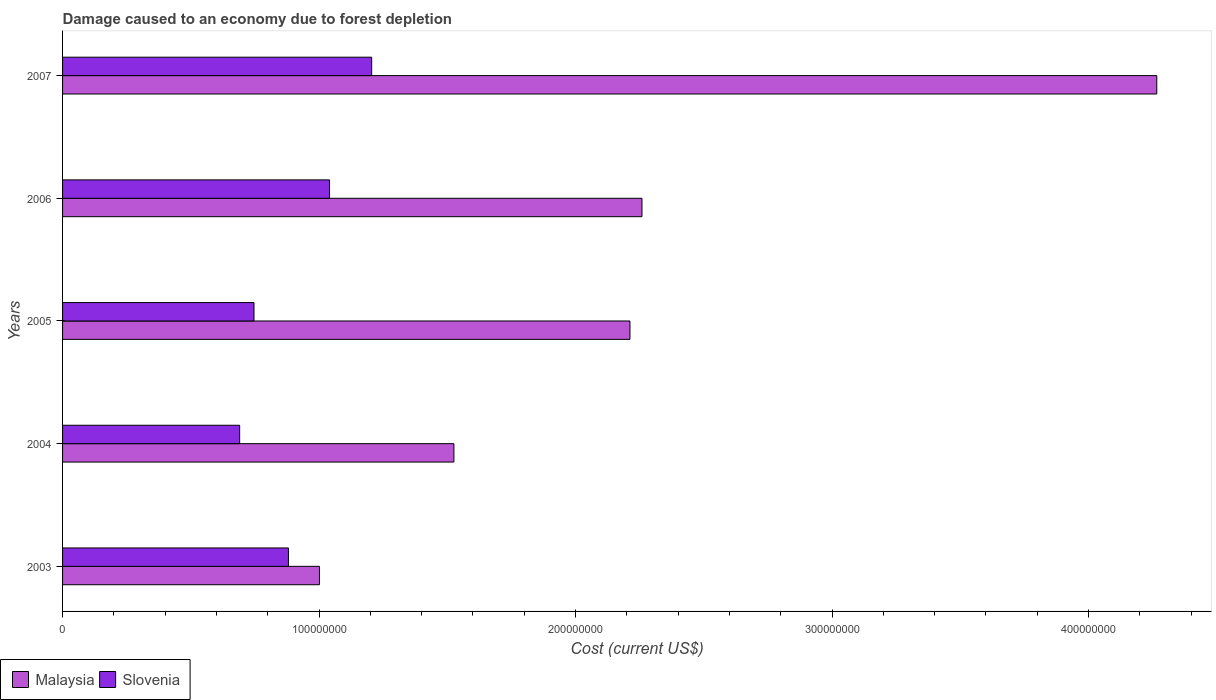How many different coloured bars are there?
Offer a very short reply. 2. How many bars are there on the 5th tick from the top?
Keep it short and to the point. 2. How many bars are there on the 5th tick from the bottom?
Offer a terse response. 2. What is the label of the 3rd group of bars from the top?
Give a very brief answer. 2005. What is the cost of damage caused due to forest depletion in Malaysia in 2004?
Your answer should be compact. 1.53e+08. Across all years, what is the maximum cost of damage caused due to forest depletion in Malaysia?
Give a very brief answer. 4.27e+08. Across all years, what is the minimum cost of damage caused due to forest depletion in Slovenia?
Make the answer very short. 6.90e+07. What is the total cost of damage caused due to forest depletion in Malaysia in the graph?
Keep it short and to the point. 1.13e+09. What is the difference between the cost of damage caused due to forest depletion in Malaysia in 2003 and that in 2004?
Provide a short and direct response. -5.24e+07. What is the difference between the cost of damage caused due to forest depletion in Slovenia in 2007 and the cost of damage caused due to forest depletion in Malaysia in 2003?
Provide a succinct answer. 2.04e+07. What is the average cost of damage caused due to forest depletion in Malaysia per year?
Offer a terse response. 2.25e+08. In the year 2007, what is the difference between the cost of damage caused due to forest depletion in Malaysia and cost of damage caused due to forest depletion in Slovenia?
Make the answer very short. 3.06e+08. What is the ratio of the cost of damage caused due to forest depletion in Slovenia in 2004 to that in 2006?
Your answer should be compact. 0.66. What is the difference between the highest and the second highest cost of damage caused due to forest depletion in Slovenia?
Your answer should be compact. 1.64e+07. What is the difference between the highest and the lowest cost of damage caused due to forest depletion in Malaysia?
Keep it short and to the point. 3.26e+08. In how many years, is the cost of damage caused due to forest depletion in Malaysia greater than the average cost of damage caused due to forest depletion in Malaysia taken over all years?
Offer a very short reply. 2. What does the 1st bar from the top in 2003 represents?
Keep it short and to the point. Slovenia. What does the 1st bar from the bottom in 2006 represents?
Your answer should be very brief. Malaysia. How many bars are there?
Ensure brevity in your answer.  10. Are all the bars in the graph horizontal?
Keep it short and to the point. Yes. How many years are there in the graph?
Offer a terse response. 5. Are the values on the major ticks of X-axis written in scientific E-notation?
Provide a succinct answer. No. Does the graph contain grids?
Ensure brevity in your answer.  No. How many legend labels are there?
Offer a terse response. 2. What is the title of the graph?
Your response must be concise. Damage caused to an economy due to forest depletion. Does "Ecuador" appear as one of the legend labels in the graph?
Your response must be concise. No. What is the label or title of the X-axis?
Make the answer very short. Cost (current US$). What is the label or title of the Y-axis?
Provide a succinct answer. Years. What is the Cost (current US$) of Malaysia in 2003?
Offer a terse response. 1.00e+08. What is the Cost (current US$) in Slovenia in 2003?
Your answer should be compact. 8.81e+07. What is the Cost (current US$) of Malaysia in 2004?
Your answer should be very brief. 1.53e+08. What is the Cost (current US$) in Slovenia in 2004?
Provide a short and direct response. 6.90e+07. What is the Cost (current US$) of Malaysia in 2005?
Ensure brevity in your answer.  2.21e+08. What is the Cost (current US$) in Slovenia in 2005?
Provide a short and direct response. 7.46e+07. What is the Cost (current US$) in Malaysia in 2006?
Your response must be concise. 2.26e+08. What is the Cost (current US$) in Slovenia in 2006?
Offer a very short reply. 1.04e+08. What is the Cost (current US$) in Malaysia in 2007?
Provide a short and direct response. 4.27e+08. What is the Cost (current US$) in Slovenia in 2007?
Provide a succinct answer. 1.21e+08. Across all years, what is the maximum Cost (current US$) of Malaysia?
Ensure brevity in your answer.  4.27e+08. Across all years, what is the maximum Cost (current US$) in Slovenia?
Make the answer very short. 1.21e+08. Across all years, what is the minimum Cost (current US$) of Malaysia?
Offer a terse response. 1.00e+08. Across all years, what is the minimum Cost (current US$) of Slovenia?
Ensure brevity in your answer.  6.90e+07. What is the total Cost (current US$) of Malaysia in the graph?
Offer a terse response. 1.13e+09. What is the total Cost (current US$) of Slovenia in the graph?
Your response must be concise. 4.56e+08. What is the difference between the Cost (current US$) in Malaysia in 2003 and that in 2004?
Provide a short and direct response. -5.24e+07. What is the difference between the Cost (current US$) of Slovenia in 2003 and that in 2004?
Offer a very short reply. 1.90e+07. What is the difference between the Cost (current US$) of Malaysia in 2003 and that in 2005?
Provide a short and direct response. -1.21e+08. What is the difference between the Cost (current US$) of Slovenia in 2003 and that in 2005?
Give a very brief answer. 1.34e+07. What is the difference between the Cost (current US$) in Malaysia in 2003 and that in 2006?
Provide a succinct answer. -1.26e+08. What is the difference between the Cost (current US$) in Slovenia in 2003 and that in 2006?
Provide a succinct answer. -1.60e+07. What is the difference between the Cost (current US$) in Malaysia in 2003 and that in 2007?
Your answer should be very brief. -3.26e+08. What is the difference between the Cost (current US$) in Slovenia in 2003 and that in 2007?
Give a very brief answer. -3.25e+07. What is the difference between the Cost (current US$) of Malaysia in 2004 and that in 2005?
Your answer should be very brief. -6.86e+07. What is the difference between the Cost (current US$) of Slovenia in 2004 and that in 2005?
Offer a terse response. -5.59e+06. What is the difference between the Cost (current US$) of Malaysia in 2004 and that in 2006?
Provide a succinct answer. -7.33e+07. What is the difference between the Cost (current US$) in Slovenia in 2004 and that in 2006?
Provide a succinct answer. -3.50e+07. What is the difference between the Cost (current US$) in Malaysia in 2004 and that in 2007?
Offer a terse response. -2.74e+08. What is the difference between the Cost (current US$) of Slovenia in 2004 and that in 2007?
Give a very brief answer. -5.15e+07. What is the difference between the Cost (current US$) in Malaysia in 2005 and that in 2006?
Give a very brief answer. -4.68e+06. What is the difference between the Cost (current US$) in Slovenia in 2005 and that in 2006?
Make the answer very short. -2.94e+07. What is the difference between the Cost (current US$) in Malaysia in 2005 and that in 2007?
Provide a short and direct response. -2.05e+08. What is the difference between the Cost (current US$) of Slovenia in 2005 and that in 2007?
Your answer should be very brief. -4.59e+07. What is the difference between the Cost (current US$) of Malaysia in 2006 and that in 2007?
Give a very brief answer. -2.01e+08. What is the difference between the Cost (current US$) in Slovenia in 2006 and that in 2007?
Provide a succinct answer. -1.64e+07. What is the difference between the Cost (current US$) in Malaysia in 2003 and the Cost (current US$) in Slovenia in 2004?
Your response must be concise. 3.11e+07. What is the difference between the Cost (current US$) in Malaysia in 2003 and the Cost (current US$) in Slovenia in 2005?
Give a very brief answer. 2.55e+07. What is the difference between the Cost (current US$) of Malaysia in 2003 and the Cost (current US$) of Slovenia in 2006?
Your response must be concise. -3.93e+06. What is the difference between the Cost (current US$) of Malaysia in 2003 and the Cost (current US$) of Slovenia in 2007?
Ensure brevity in your answer.  -2.04e+07. What is the difference between the Cost (current US$) in Malaysia in 2004 and the Cost (current US$) in Slovenia in 2005?
Your response must be concise. 7.79e+07. What is the difference between the Cost (current US$) in Malaysia in 2004 and the Cost (current US$) in Slovenia in 2006?
Provide a short and direct response. 4.85e+07. What is the difference between the Cost (current US$) in Malaysia in 2004 and the Cost (current US$) in Slovenia in 2007?
Your answer should be very brief. 3.21e+07. What is the difference between the Cost (current US$) in Malaysia in 2005 and the Cost (current US$) in Slovenia in 2006?
Provide a succinct answer. 1.17e+08. What is the difference between the Cost (current US$) of Malaysia in 2005 and the Cost (current US$) of Slovenia in 2007?
Keep it short and to the point. 1.01e+08. What is the difference between the Cost (current US$) in Malaysia in 2006 and the Cost (current US$) in Slovenia in 2007?
Offer a very short reply. 1.05e+08. What is the average Cost (current US$) of Malaysia per year?
Make the answer very short. 2.25e+08. What is the average Cost (current US$) in Slovenia per year?
Your answer should be very brief. 9.13e+07. In the year 2003, what is the difference between the Cost (current US$) in Malaysia and Cost (current US$) in Slovenia?
Ensure brevity in your answer.  1.21e+07. In the year 2004, what is the difference between the Cost (current US$) in Malaysia and Cost (current US$) in Slovenia?
Provide a short and direct response. 8.35e+07. In the year 2005, what is the difference between the Cost (current US$) of Malaysia and Cost (current US$) of Slovenia?
Keep it short and to the point. 1.47e+08. In the year 2006, what is the difference between the Cost (current US$) of Malaysia and Cost (current US$) of Slovenia?
Provide a succinct answer. 1.22e+08. In the year 2007, what is the difference between the Cost (current US$) of Malaysia and Cost (current US$) of Slovenia?
Offer a very short reply. 3.06e+08. What is the ratio of the Cost (current US$) in Malaysia in 2003 to that in 2004?
Make the answer very short. 0.66. What is the ratio of the Cost (current US$) in Slovenia in 2003 to that in 2004?
Ensure brevity in your answer.  1.28. What is the ratio of the Cost (current US$) of Malaysia in 2003 to that in 2005?
Your answer should be compact. 0.45. What is the ratio of the Cost (current US$) in Slovenia in 2003 to that in 2005?
Keep it short and to the point. 1.18. What is the ratio of the Cost (current US$) of Malaysia in 2003 to that in 2006?
Your response must be concise. 0.44. What is the ratio of the Cost (current US$) of Slovenia in 2003 to that in 2006?
Keep it short and to the point. 0.85. What is the ratio of the Cost (current US$) in Malaysia in 2003 to that in 2007?
Offer a terse response. 0.23. What is the ratio of the Cost (current US$) of Slovenia in 2003 to that in 2007?
Give a very brief answer. 0.73. What is the ratio of the Cost (current US$) of Malaysia in 2004 to that in 2005?
Make the answer very short. 0.69. What is the ratio of the Cost (current US$) in Slovenia in 2004 to that in 2005?
Offer a terse response. 0.93. What is the ratio of the Cost (current US$) in Malaysia in 2004 to that in 2006?
Make the answer very short. 0.68. What is the ratio of the Cost (current US$) in Slovenia in 2004 to that in 2006?
Your response must be concise. 0.66. What is the ratio of the Cost (current US$) of Malaysia in 2004 to that in 2007?
Give a very brief answer. 0.36. What is the ratio of the Cost (current US$) in Slovenia in 2004 to that in 2007?
Make the answer very short. 0.57. What is the ratio of the Cost (current US$) of Malaysia in 2005 to that in 2006?
Offer a terse response. 0.98. What is the ratio of the Cost (current US$) of Slovenia in 2005 to that in 2006?
Your answer should be compact. 0.72. What is the ratio of the Cost (current US$) of Malaysia in 2005 to that in 2007?
Provide a short and direct response. 0.52. What is the ratio of the Cost (current US$) in Slovenia in 2005 to that in 2007?
Your answer should be very brief. 0.62. What is the ratio of the Cost (current US$) of Malaysia in 2006 to that in 2007?
Make the answer very short. 0.53. What is the ratio of the Cost (current US$) in Slovenia in 2006 to that in 2007?
Keep it short and to the point. 0.86. What is the difference between the highest and the second highest Cost (current US$) in Malaysia?
Provide a succinct answer. 2.01e+08. What is the difference between the highest and the second highest Cost (current US$) of Slovenia?
Keep it short and to the point. 1.64e+07. What is the difference between the highest and the lowest Cost (current US$) of Malaysia?
Your answer should be very brief. 3.26e+08. What is the difference between the highest and the lowest Cost (current US$) in Slovenia?
Keep it short and to the point. 5.15e+07. 